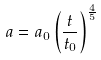<formula> <loc_0><loc_0><loc_500><loc_500>a = a _ { 0 } \left ( \frac { t } { t _ { 0 } } \right ) ^ { \frac { 4 } { 5 } }</formula> 